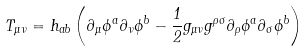<formula> <loc_0><loc_0><loc_500><loc_500>T _ { \mu \nu } = h _ { a b } \left ( \partial _ { \mu } \phi ^ { a } \partial _ { \nu } \phi ^ { b } - \frac { 1 } { 2 } g _ { \mu \nu } g ^ { \rho \sigma } \partial _ { \rho } \phi ^ { a } \partial _ { \sigma } \phi ^ { b } \right )</formula> 